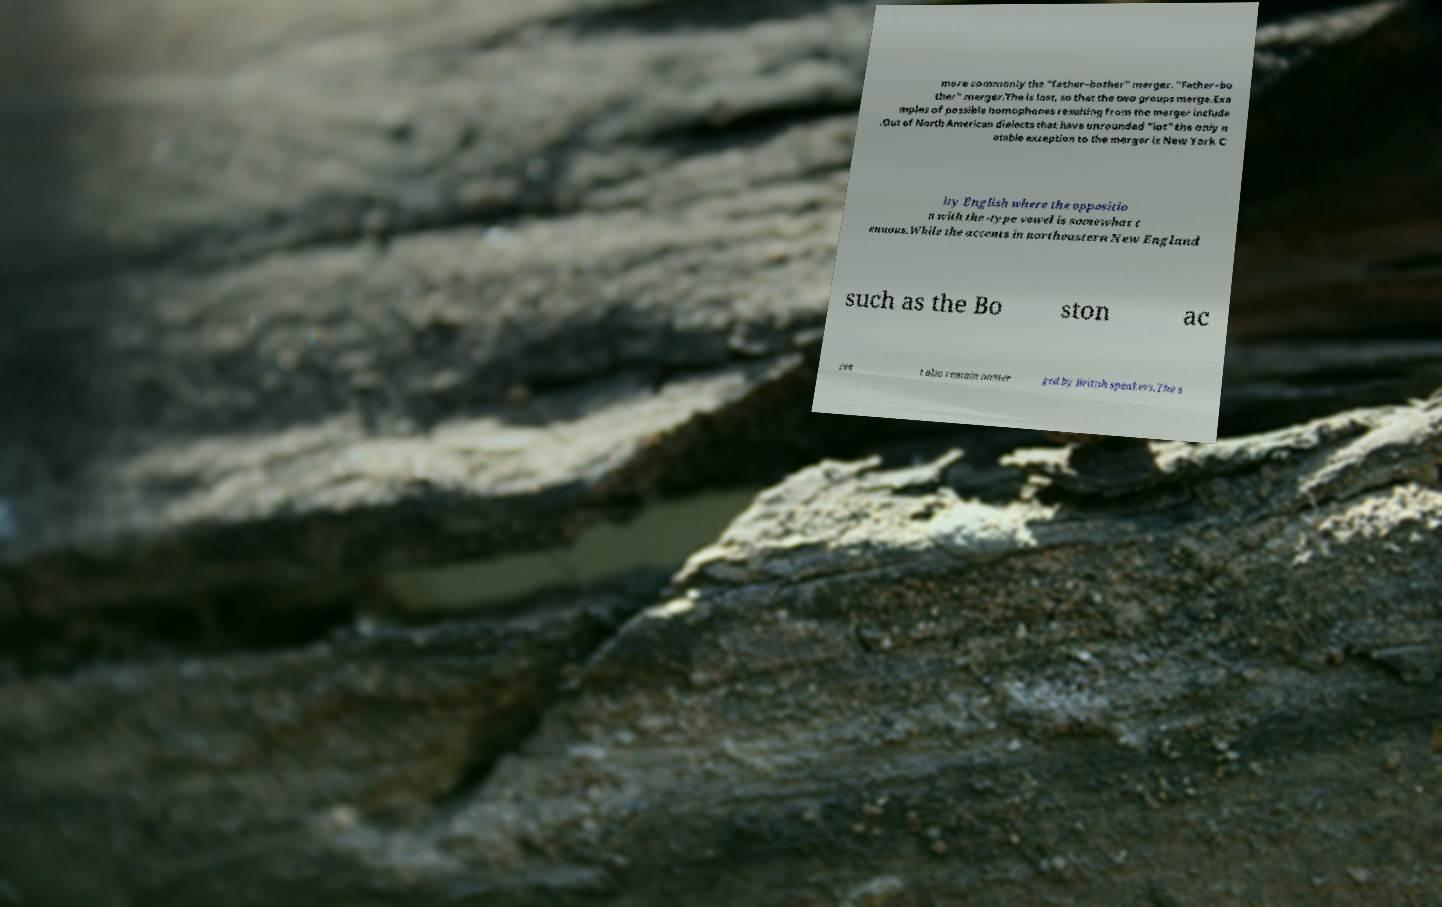What messages or text are displayed in this image? I need them in a readable, typed format. more commonly the "father–bother" merger. "Father–bo ther" merger.The is lost, so that the two groups merge.Exa mples of possible homophones resulting from the merger include .Out of North American dialects that have unrounded "lot" the only n otable exception to the merger is New York C ity English where the oppositio n with the -type vowel is somewhat t enuous.While the accents in northeastern New England such as the Bo ston ac cen t also remain unmer ged by British speakers.The s 